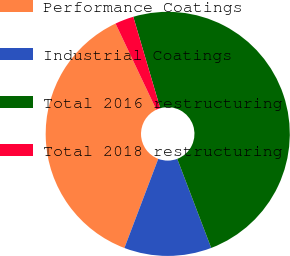Convert chart. <chart><loc_0><loc_0><loc_500><loc_500><pie_chart><fcel>Performance Coatings<fcel>Industrial Coatings<fcel>Total 2016 restructuring<fcel>Total 2018 restructuring<nl><fcel>37.19%<fcel>11.57%<fcel>48.76%<fcel>2.48%<nl></chart> 